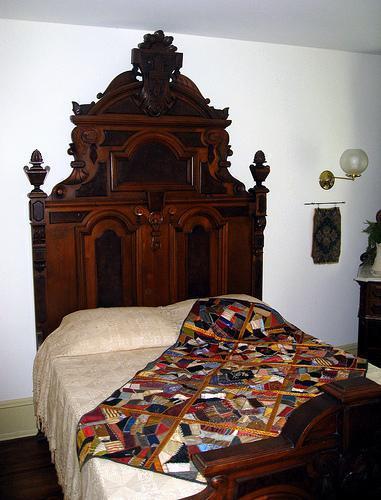How many beds are in the photo?
Give a very brief answer. 1. 